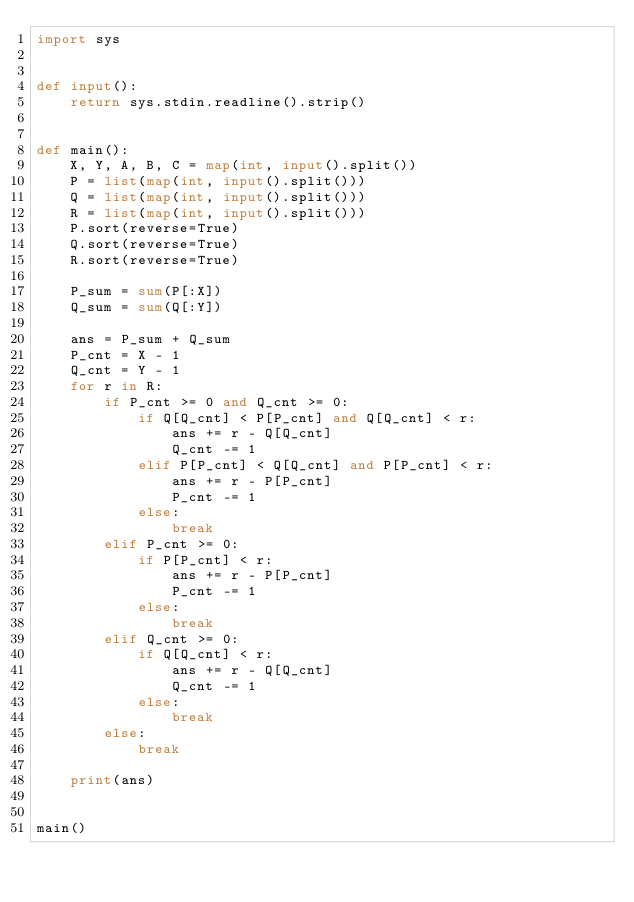<code> <loc_0><loc_0><loc_500><loc_500><_Python_>import sys


def input():
    return sys.stdin.readline().strip()


def main():
    X, Y, A, B, C = map(int, input().split())
    P = list(map(int, input().split()))
    Q = list(map(int, input().split()))
    R = list(map(int, input().split()))
    P.sort(reverse=True)
    Q.sort(reverse=True)
    R.sort(reverse=True)

    P_sum = sum(P[:X])
    Q_sum = sum(Q[:Y])

    ans = P_sum + Q_sum
    P_cnt = X - 1
    Q_cnt = Y - 1
    for r in R:
        if P_cnt >= 0 and Q_cnt >= 0:
            if Q[Q_cnt] < P[P_cnt] and Q[Q_cnt] < r:
                ans += r - Q[Q_cnt]
                Q_cnt -= 1
            elif P[P_cnt] < Q[Q_cnt] and P[P_cnt] < r:
                ans += r - P[P_cnt]
                P_cnt -= 1
            else:
                break
        elif P_cnt >= 0:
            if P[P_cnt] < r:
                ans += r - P[P_cnt]
                P_cnt -= 1
            else:
                break
        elif Q_cnt >= 0:
            if Q[Q_cnt] < r:
                ans += r - Q[Q_cnt]
                Q_cnt -= 1
            else:
                break
        else:
            break

    print(ans)


main()
</code> 